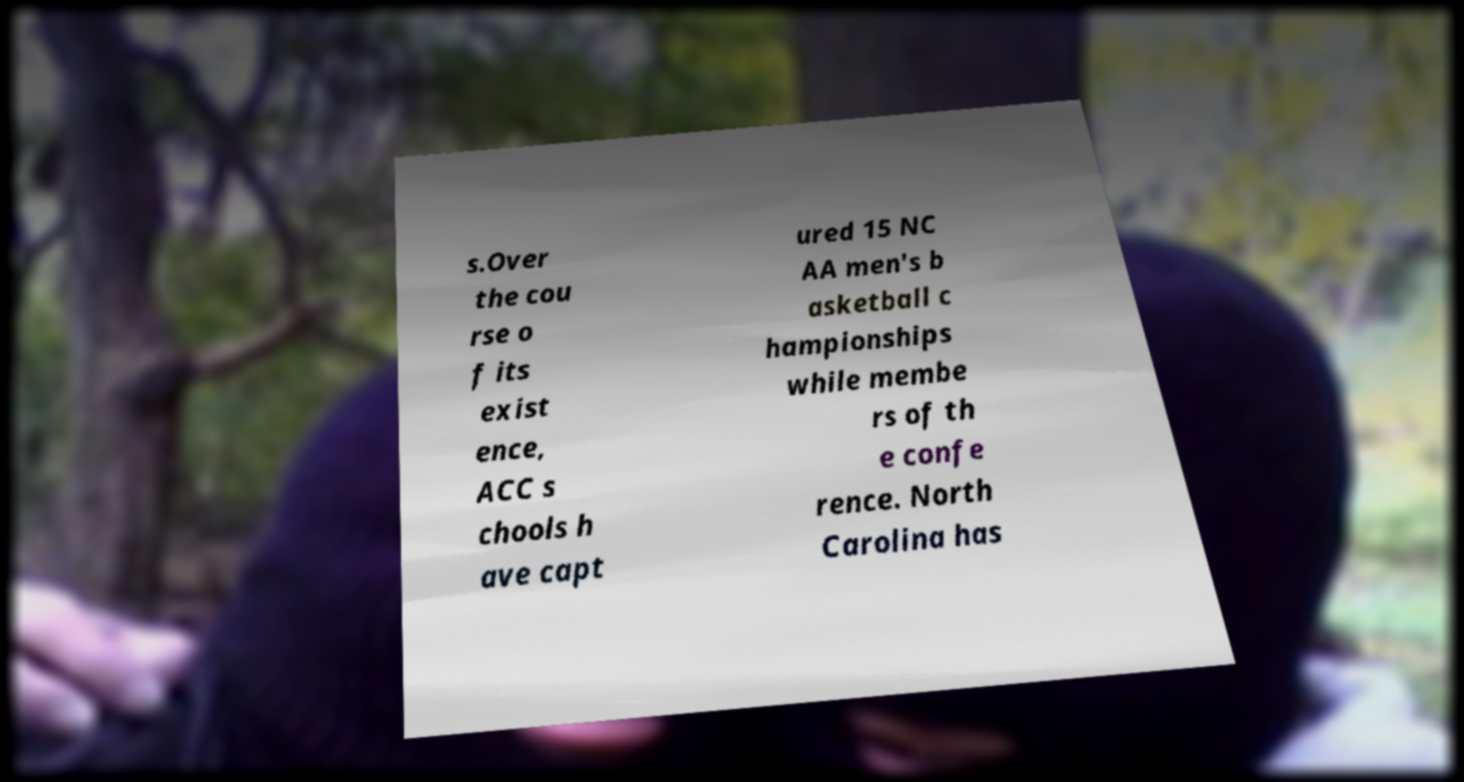There's text embedded in this image that I need extracted. Can you transcribe it verbatim? s.Over the cou rse o f its exist ence, ACC s chools h ave capt ured 15 NC AA men's b asketball c hampionships while membe rs of th e confe rence. North Carolina has 